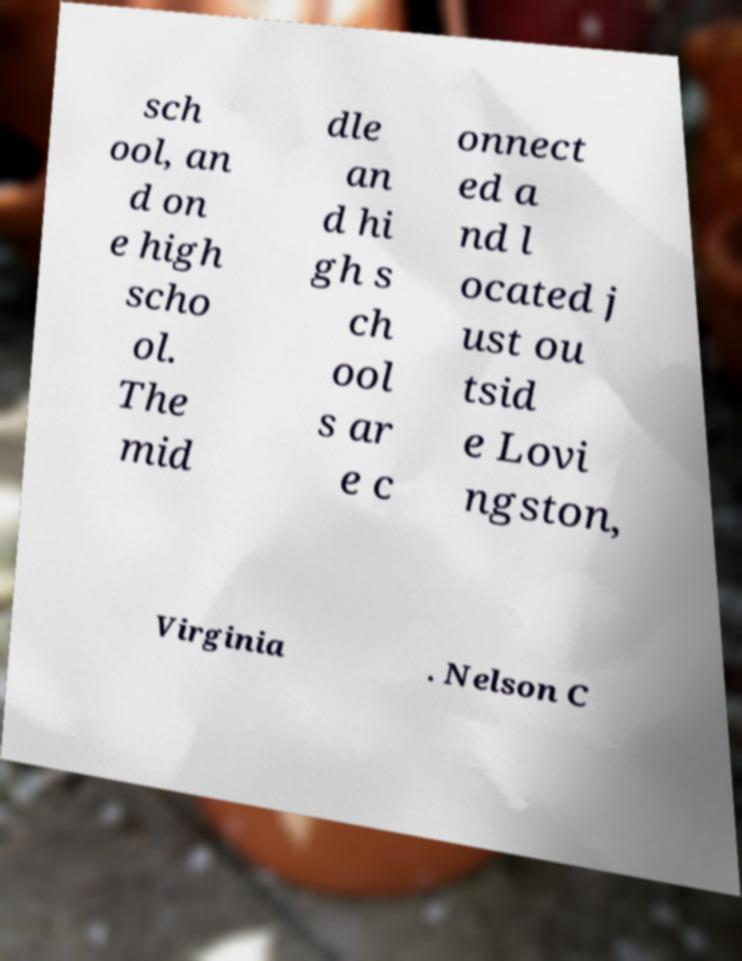There's text embedded in this image that I need extracted. Can you transcribe it verbatim? sch ool, an d on e high scho ol. The mid dle an d hi gh s ch ool s ar e c onnect ed a nd l ocated j ust ou tsid e Lovi ngston, Virginia . Nelson C 